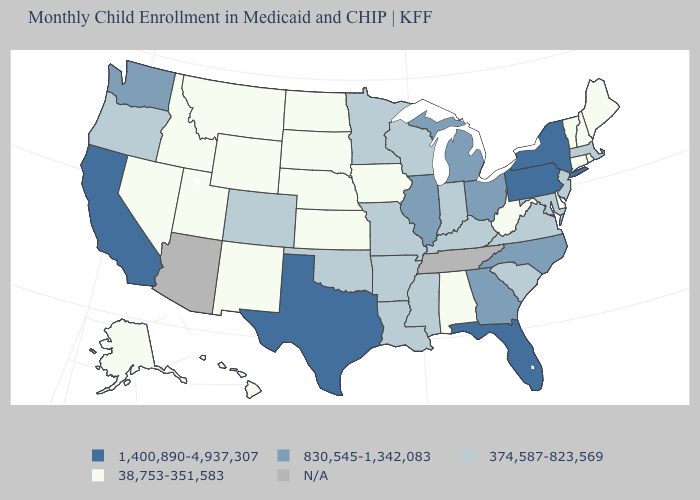Does North Dakota have the lowest value in the MidWest?
Give a very brief answer. Yes. What is the value of Pennsylvania?
Concise answer only. 1,400,890-4,937,307. How many symbols are there in the legend?
Give a very brief answer. 5. Among the states that border North Carolina , does Georgia have the highest value?
Keep it brief. Yes. Name the states that have a value in the range 374,587-823,569?
Give a very brief answer. Arkansas, Colorado, Indiana, Kentucky, Louisiana, Maryland, Massachusetts, Minnesota, Mississippi, Missouri, New Jersey, Oklahoma, Oregon, South Carolina, Virginia, Wisconsin. What is the lowest value in the West?
Keep it brief. 38,753-351,583. Does Indiana have the lowest value in the USA?
Quick response, please. No. Name the states that have a value in the range 830,545-1,342,083?
Give a very brief answer. Georgia, Illinois, Michigan, North Carolina, Ohio, Washington. Name the states that have a value in the range 1,400,890-4,937,307?
Concise answer only. California, Florida, New York, Pennsylvania, Texas. What is the lowest value in the South?
Write a very short answer. 38,753-351,583. What is the highest value in the MidWest ?
Short answer required. 830,545-1,342,083. What is the value of Maine?
Give a very brief answer. 38,753-351,583. What is the value of New Mexico?
Write a very short answer. 38,753-351,583. Does the first symbol in the legend represent the smallest category?
Answer briefly. No. 